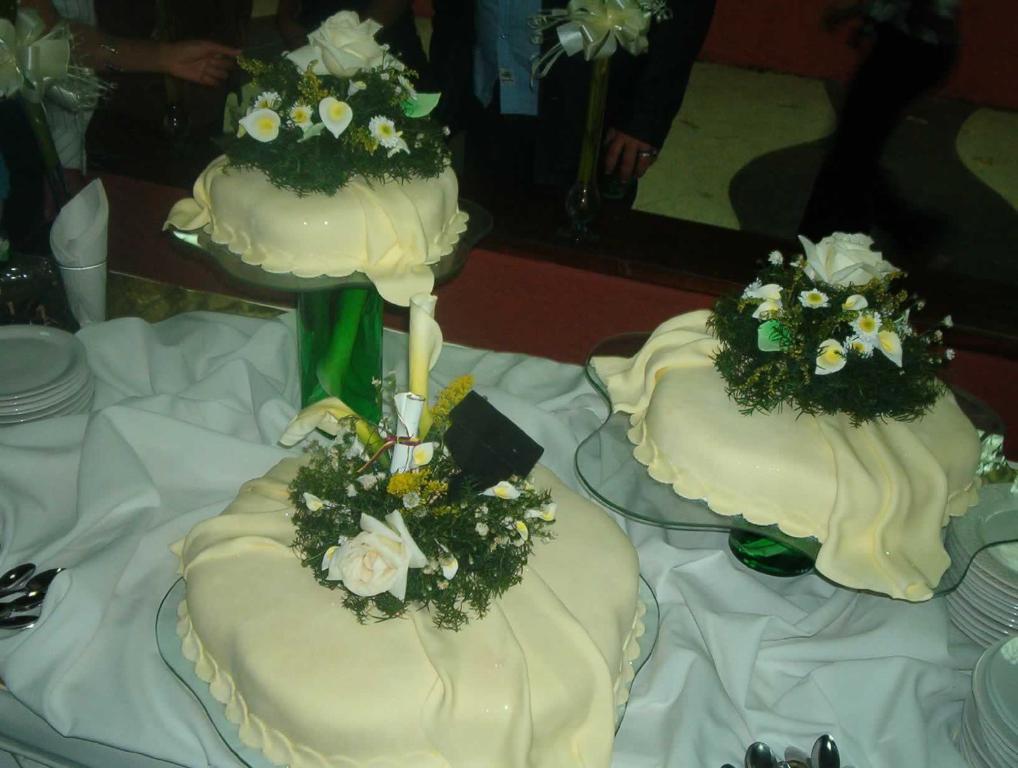Could you give a brief overview of what you see in this image? In this image, there are a few people. We can see some objects on glass stands. We can see some ribbons, plates, spoons and some cloth. 